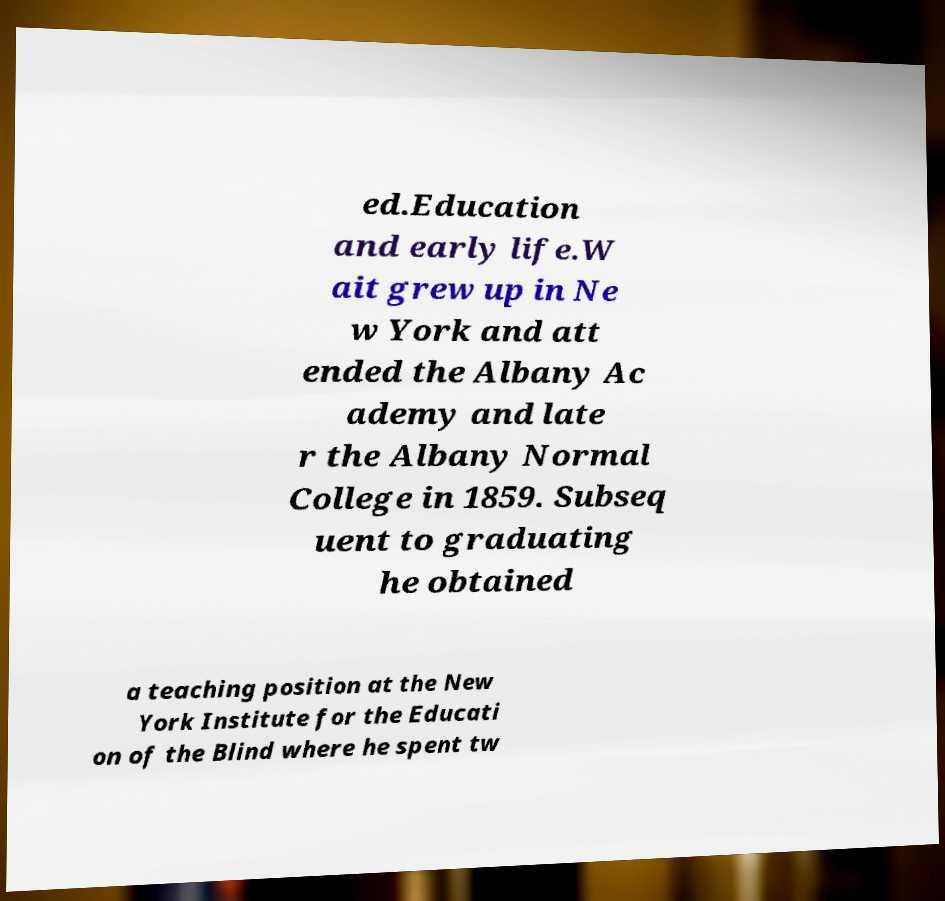Please identify and transcribe the text found in this image. ed.Education and early life.W ait grew up in Ne w York and att ended the Albany Ac ademy and late r the Albany Normal College in 1859. Subseq uent to graduating he obtained a teaching position at the New York Institute for the Educati on of the Blind where he spent tw 